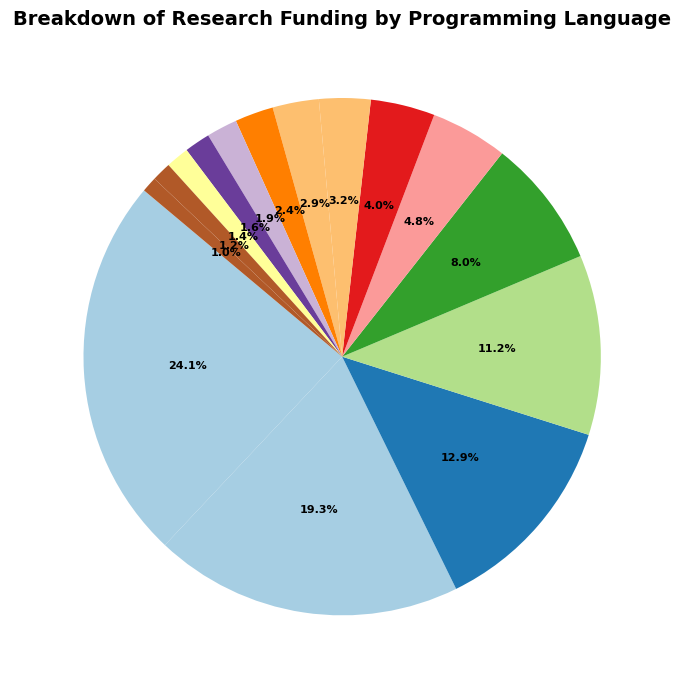What percentage of the total funding is allocated to Python? First, find the Python funding amount which is $1,500,000. The total funding is the sum of all language funding amounts: $1,500,000 + $1,200,000 + $800,000 + $700,000 + $500,000 + $300,000 + $250,000 + $200,000 + $180,000 + $150,000 + $120,000 + $100,000 + $90,000 + $75,000 + $60,000 = $5,925,000. The percentage is calculated by ($1,500,000 / $5,925,000) * 100% ≈ 25.3%
Answer: 25.3% Which programming language has the second highest funding? The pie chart visually shows the largest segment for Python, followed by the next largest for Java. Thus, Java has the second highest funding at $1,200,000.
Answer: Java How does the funding for Ruby compare to Go? The funding for Ruby is $300,000 while the funding for Go is $250,000. Ruby has a slightly higher funding than Go.
Answer: Ruby has more funding than Go What is the total funding for languages with less than 1% funding each? First, identify languages with less than 1% funding: Haskell, Scala, Lua, and Rust. Summing them up: $100,000 + $90,000 + $75,000 + $60,000 = $325,000. Now, verify they are less than 1%. Total funding is $5,925,000. 1% of total funding is $59,250. Each of these languages' funding is less than $59,250. Therefore, their total funding is $325,000
Answer: $325,000 What's the combined funding percentage for both JavaScript and C++? The funding for JavaScript is $800,000 and for C++ is $700,000. Summing them gives $1,500,000. The total funding is $5,925,000. Calculate the percentage by ($1,500,000 / $5,925,000) * 100% ≈ 25.3%.
Answer: 25.3% If funding for Python and Java were combined, would it exceed half of the total funding? Combined funding for Python and Java: $1,500,000 + $1,200,000 = $2,700,000. Half of the total funding: $5,925,000 / 2 = $2,962,500. Since $2,700,000 < $2,962,500, it would not exceed half.
Answer: No Among the languages with funding less than $300,000, which one has the highest funding? The languages with funding less than $300,000 are Go, Swift, Kotlin, Perl, MATLAB, Haskell, Scala, Lua, and Rust. Among these, MATLAB has the highest funding at $120,000.
Answer: MATLAB What is the funding difference between Swift and Kotlin? Swift has $200,000 in funding and Kotlin has $180,000. The difference is $200,000 - $180,000 = $20,000.
Answer: $20,000 Which language occupies the largest portion of the pie chart in terms of visual space? The language with the largest segment is Python.
Answer: Python 